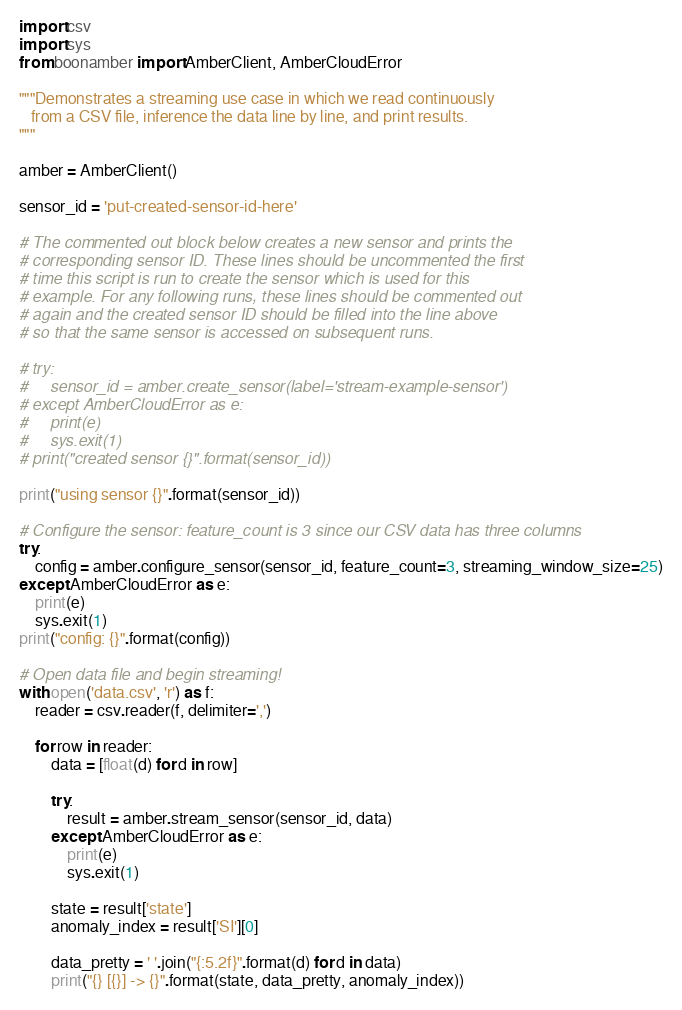<code> <loc_0><loc_0><loc_500><loc_500><_Python_>import csv
import sys
from boonamber import AmberClient, AmberCloudError

"""Demonstrates a streaming use case in which we read continuously
   from a CSV file, inference the data line by line, and print results.
"""

amber = AmberClient()

sensor_id = 'put-created-sensor-id-here'

# The commented out block below creates a new sensor and prints the
# corresponding sensor ID. These lines should be uncommented the first
# time this script is run to create the sensor which is used for this
# example. For any following runs, these lines should be commented out
# again and the created sensor ID should be filled into the line above
# so that the same sensor is accessed on subsequent runs.

# try:
#     sensor_id = amber.create_sensor(label='stream-example-sensor')
# except AmberCloudError as e:
#     print(e)
#     sys.exit(1)
# print("created sensor {}".format(sensor_id))

print("using sensor {}".format(sensor_id))

# Configure the sensor: feature_count is 3 since our CSV data has three columns
try:
    config = amber.configure_sensor(sensor_id, feature_count=3, streaming_window_size=25)
except AmberCloudError as e:
    print(e)
    sys.exit(1)
print("config: {}".format(config))

# Open data file and begin streaming!
with open('data.csv', 'r') as f:
    reader = csv.reader(f, delimiter=',')

    for row in reader:
        data = [float(d) for d in row]

        try:
            result = amber.stream_sensor(sensor_id, data)
        except AmberCloudError as e:
            print(e)
            sys.exit(1)

        state = result['state']
        anomaly_index = result['SI'][0]

        data_pretty = ' '.join("{:5.2f}".format(d) for d in data)
        print("{} [{}] -> {}".format(state, data_pretty, anomaly_index))
</code> 